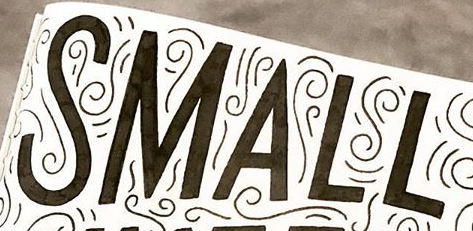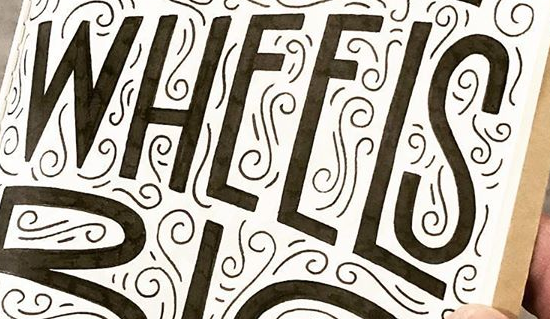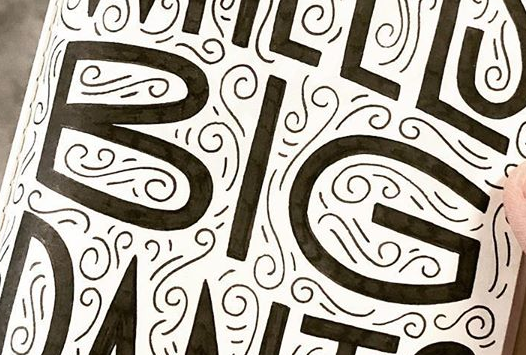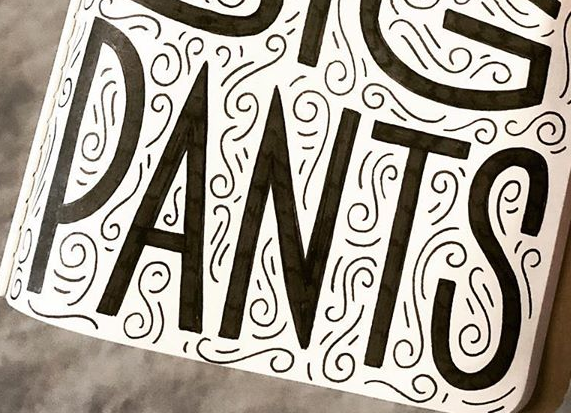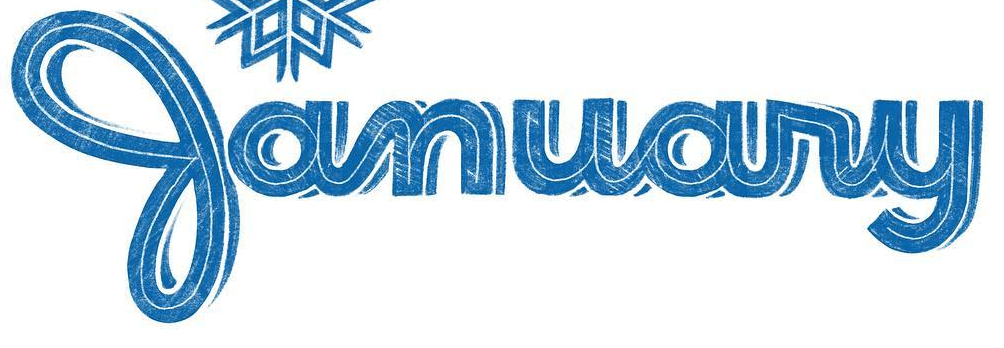Read the text from these images in sequence, separated by a semicolon. SMALL; WHEELS; BIG; PANTS; January 